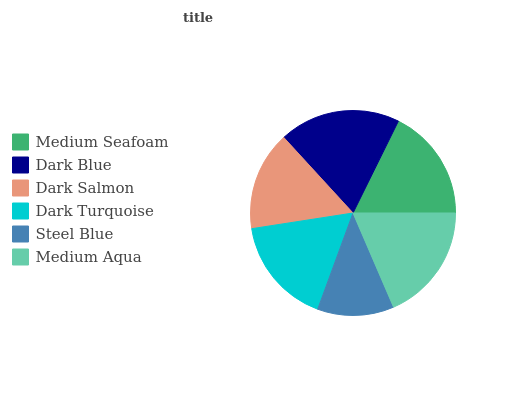Is Steel Blue the minimum?
Answer yes or no. Yes. Is Dark Blue the maximum?
Answer yes or no. Yes. Is Dark Salmon the minimum?
Answer yes or no. No. Is Dark Salmon the maximum?
Answer yes or no. No. Is Dark Blue greater than Dark Salmon?
Answer yes or no. Yes. Is Dark Salmon less than Dark Blue?
Answer yes or no. Yes. Is Dark Salmon greater than Dark Blue?
Answer yes or no. No. Is Dark Blue less than Dark Salmon?
Answer yes or no. No. Is Medium Seafoam the high median?
Answer yes or no. Yes. Is Dark Turquoise the low median?
Answer yes or no. Yes. Is Dark Salmon the high median?
Answer yes or no. No. Is Dark Blue the low median?
Answer yes or no. No. 